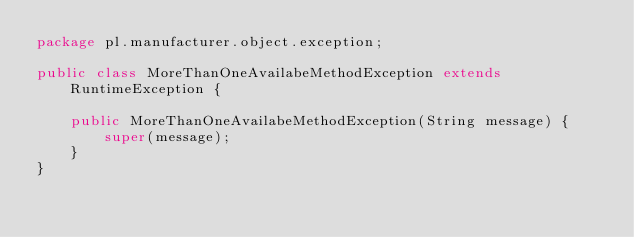<code> <loc_0><loc_0><loc_500><loc_500><_Java_>package pl.manufacturer.object.exception;

public class MoreThanOneAvailabeMethodException extends RuntimeException {

    public MoreThanOneAvailabeMethodException(String message) {
        super(message);
    }
}
</code> 